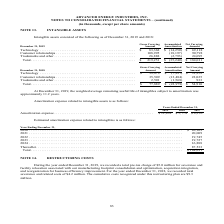From Advanced Energy's financial document, Which years does the table provide data for intangible assets? The document shows two values: 2019 and 2018. From the document: "ets consisted of the following as of December 31, 2019 and 2018: sted of the following as of December 31, 2019 and 2018:..." Also, What was the gross carrying amount of Technology in 2019? According to the financial document, $83,368 (in thousands). The relevant text states: "1, 2019 Amount Amortization Amount Technology . $ 83,368 $ (14,250) $ 69,118..." Also, What was the accumulated amortization of customer relationships in 2018? According to the financial document, (13,484) (in thousands). The relevant text states: "Customer relationships . 35,509 (13,484) 22,025 Trademarks and other . 2,501 (1,568) 933 Total . $ 77,889 $ (22,979) $ 54,910..." Also, can you calculate: What is the sum of the two highest gross carrying amounts in 2019? Based on the calculation: 83,368+108,995, the result is 192363 (in thousands). This is based on the information: "1, 2019 Amount Amortization Amount Technology . $ 83,368 $ (14,250) $ 69,118 Customer relationships . 108,995 (18,197) 90,798 Trademarks and other . 26,888 (2,793) 24,095 Total . $ 219,251 $ (35,240) ..." The key data points involved are: 108,995, 83,368. Additionally, What was the two highest net carrying amounts segments in 2018? The document shows two values: Technology and Customer relationships (in thousands). From the document: "ying December 31, 2019 Amount Amortization Amount Technology . $ 83,368 $ (14,250) $ 69,118 Customer relationships . 108,995 (18,197) 90,798 Trademark..." Also, can you calculate: What was the percentage change in the total gross carrying amount between 2018 and 2019? To answer this question, I need to perform calculations using the financial data. The calculation is: ($219,251-$77,889)/$77,889, which equals 181.49 (percentage). This is based on the information: "marks and other . 26,888 (2,793) 24,095 Total . $ 219,251 $ (35,240) $ 184,011 rademarks and other . 2,501 (1,568) 933 Total . $ 77,889 $ (22,979) $ 54,910..." The key data points involved are: 219,251, 77,889. 